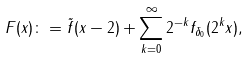Convert formula to latex. <formula><loc_0><loc_0><loc_500><loc_500>F ( x ) \colon = \tilde { f } ( x - 2 ) + \sum _ { k = 0 } ^ { \infty } 2 ^ { - k } f _ { \delta _ { 0 } } ( 2 ^ { k } x ) ,</formula> 